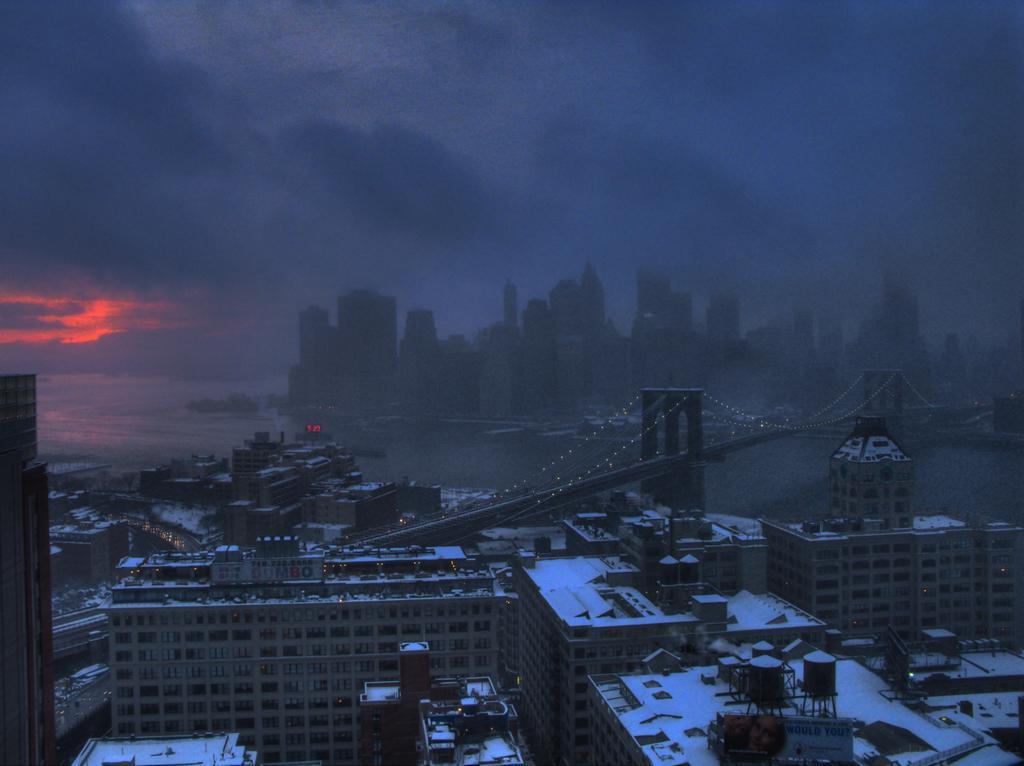Could you give a brief overview of what you see in this image? In this picture we can observe some buildings. There is a bridge across the river. We can observe some snow on the buildings. In the background there is a river and a sky with some clouds. 